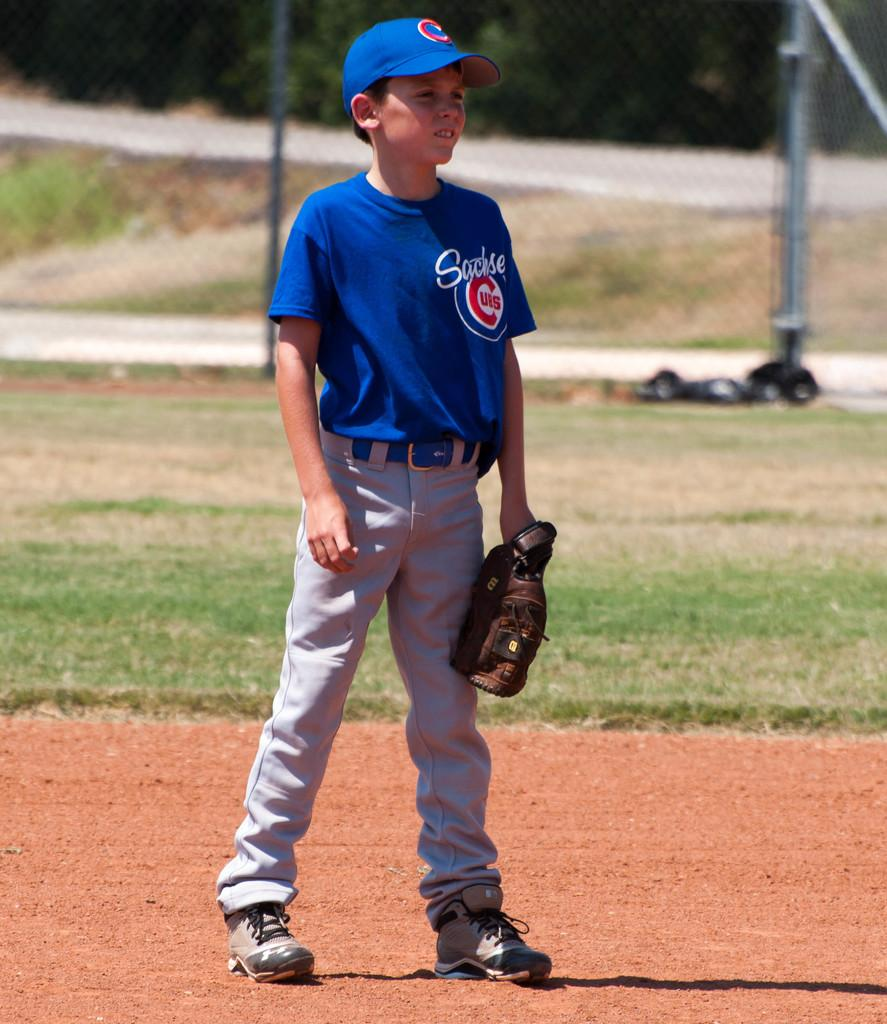<image>
Offer a succinct explanation of the picture presented. A boy wears a Cubs jersey on a baseball field. 